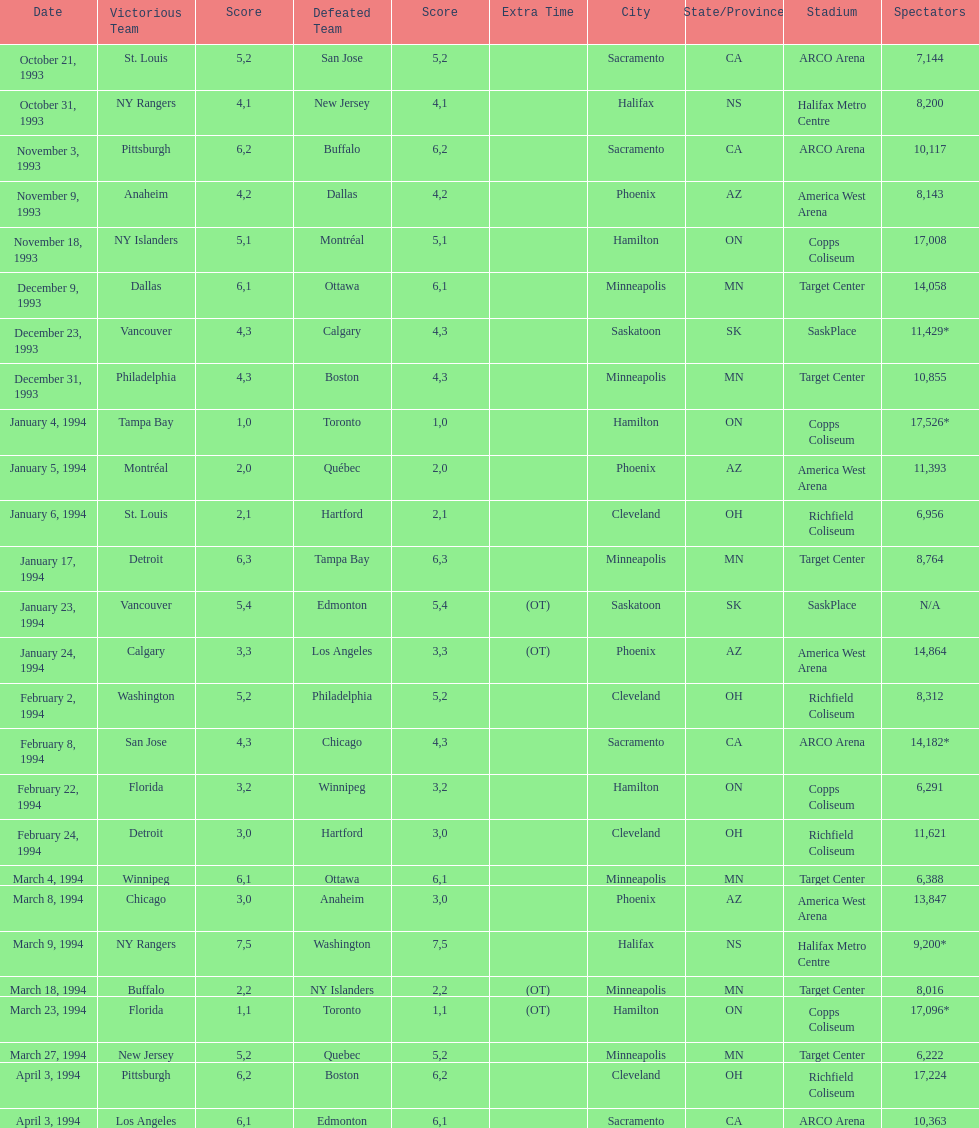The game on which date had the most attendance? January 4, 1994. 